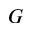<formula> <loc_0><loc_0><loc_500><loc_500>G</formula> 